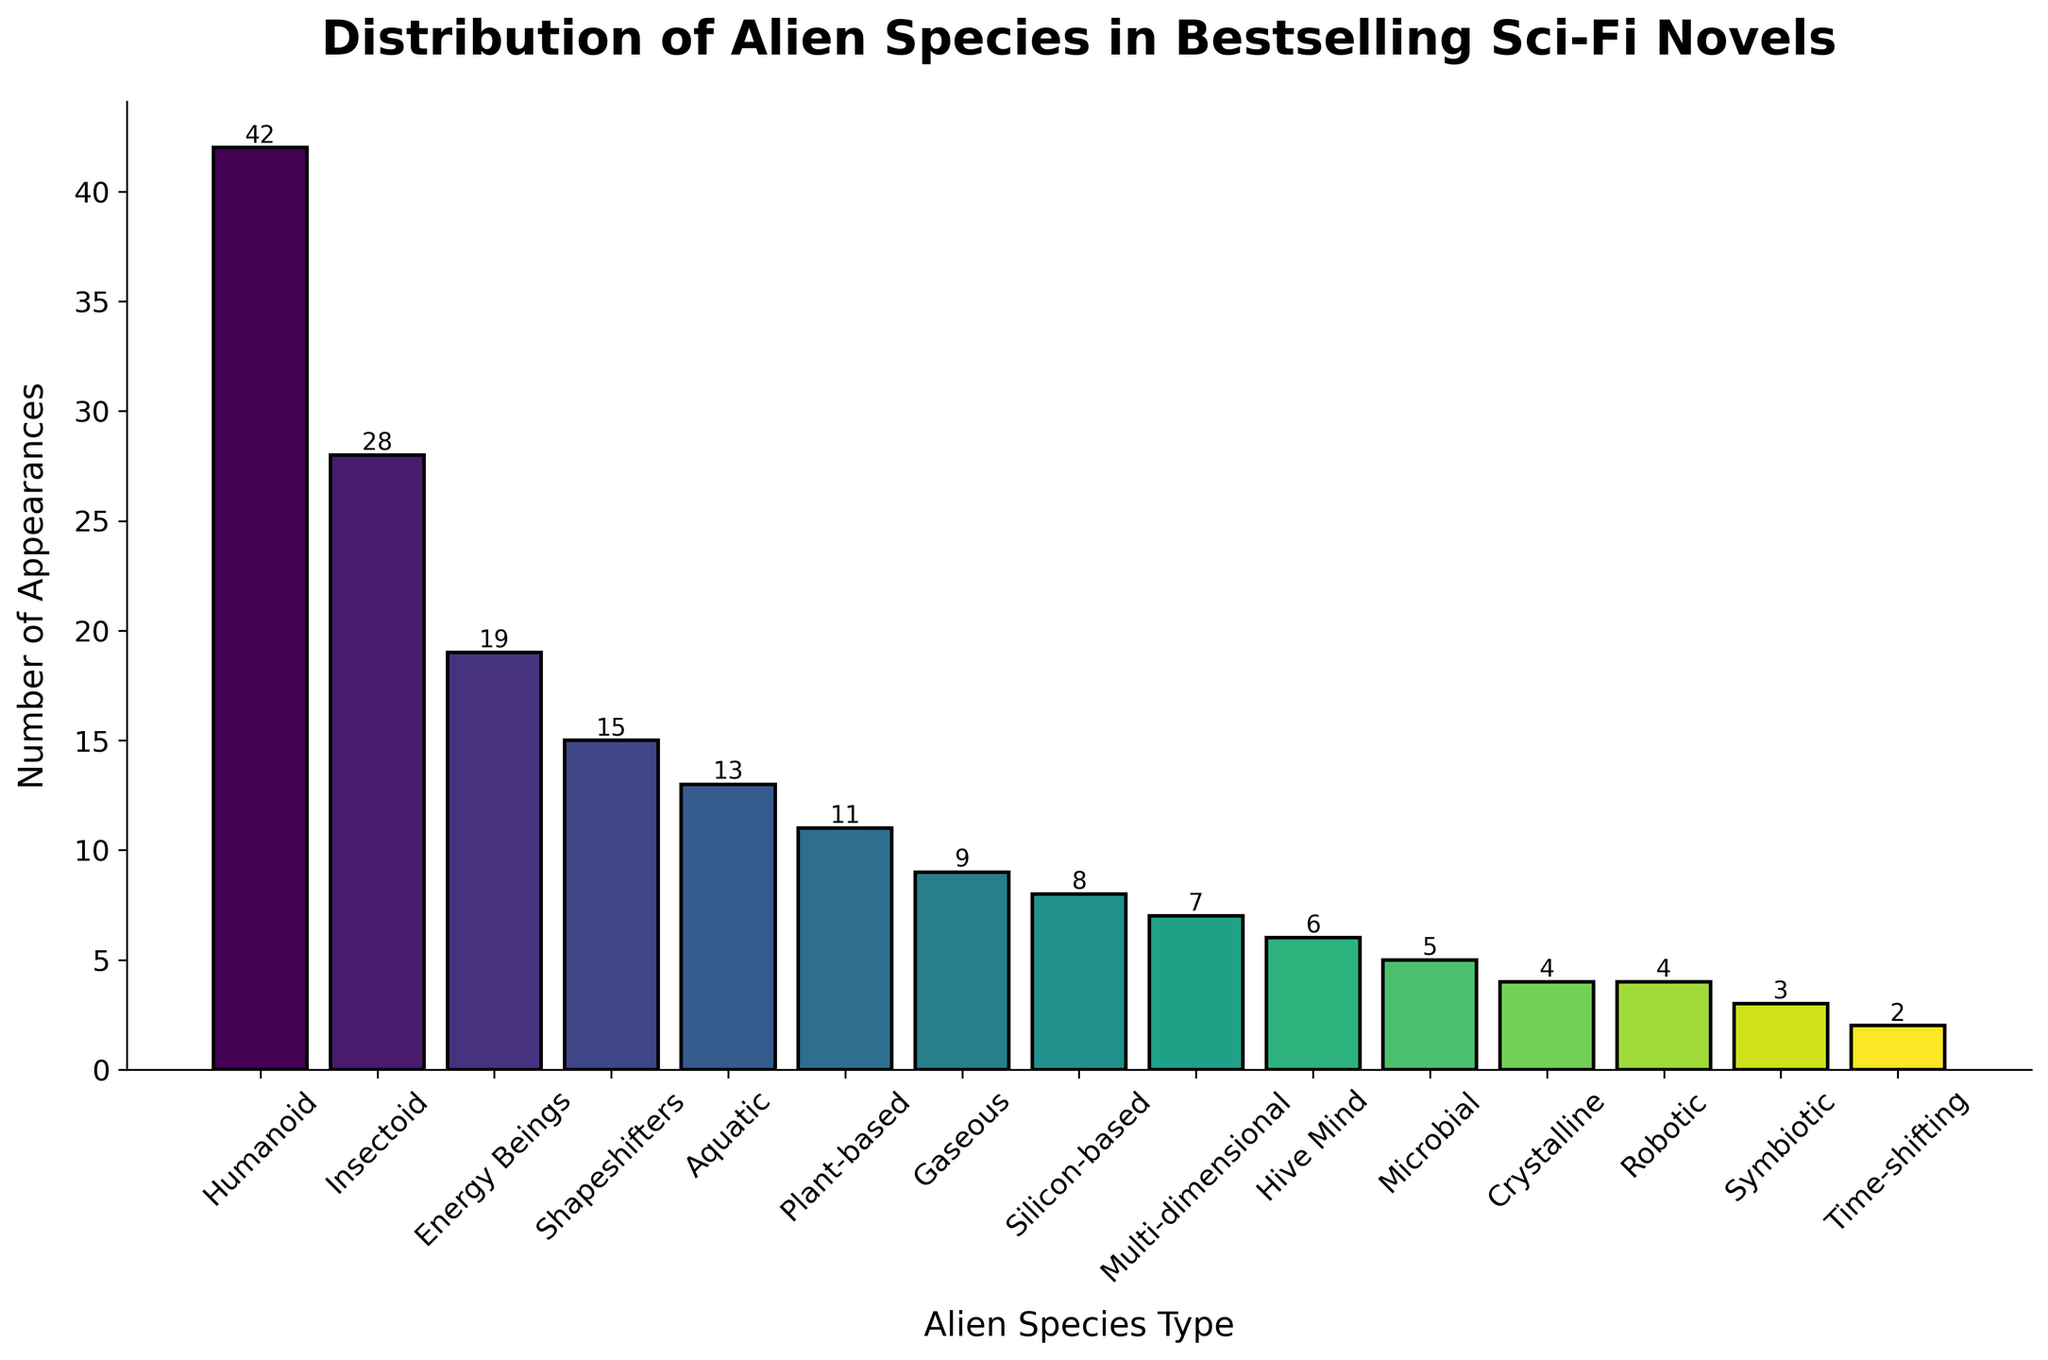What is the most common type of alien species in bestselling sci-fi novels? The height of the bars represents the number of appearances of each alien species type. The tallest bar corresponds to "Humanoid" with 42 appearances.
Answer: Humanoid Which alien species types appear less frequently than Plant-based but more frequently than Crystalline? From the chart, Plant-based has 11 appearances while Crystalline has 4. The species that fall in this range of 5 to 10 appearances are Gaseous (9), Silicon-based (8), Multi-dimensional (7), and Hive Mind (6).
Answer: Gaseous, Silicon-based, Multi-dimensional, Hive Mind What is the combined number of appearances for the top three most frequently occurring alien species types? The top three types are Humanoid (42), Insectoid (28), and Energy Beings (19). Summing these gives 42 + 28 + 19 = 89.
Answer: 89 How many alien species types have fewer than 10 appearances? From the chart, the species with fewer than 10 appearances are Gaseous (9), Silicon-based (8), Multi-dimensional (7), Hive Mind (6), Microbial (5), Crystalline (4), Robotic (4), Symbiotic (3), Time-shifting (2). There are 9 species in total.
Answer: 9 What is the least common alien species type and how many times does it appear? From the chart, the smallest bar corresponds to "Time-shifting" with 2 appearances.
Answer: Time-shifting, 2 Compare the number of appearances between Aquatic and Plant-based species. Aquatic appears 13 times, while Plant-based appears 11 times. Therefore, Aquatic appears more frequently than Plant-based.
Answer: Aquatic > Plant-based How many less frequent are Crystalline alien species than Humanoid? Humanoid appears 42 times, while Crystalline appears 4 times. The difference is 42 - 4 = 38.
Answer: 38 What is the median number of appearances for all alien species types listed? Arrange the appearances in ascending order: 2, 3, 4, 4, 5, 6, 7, 8, 9, 11, 13, 15, 19, 28, 42. The median is the middle value, which is 9.
Answer: 9 What is the difference in the number of appearances between Energy Beings and Shapeshifters? Energy Beings appear 19 times and Shapeshifters appear 15 times. The difference is 19 - 15 = 4.
Answer: 4 Which alien species type exhibits a middle standing in the number of appearances and how many times does it appear? Given the number of appearances in ascending order (2, 3, 4, 4, 5, 6, 7, 8, 9, 11, 13, 15, 19, 28, 42), the middle value is 9. The species with this number is Gaseous.
Answer: Gaseous, 9 